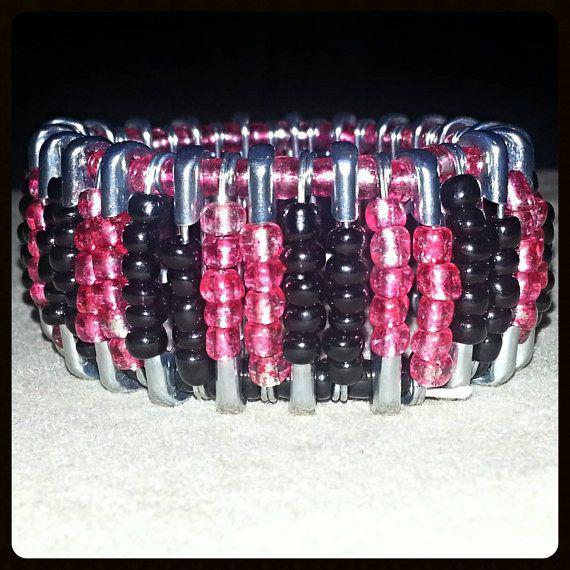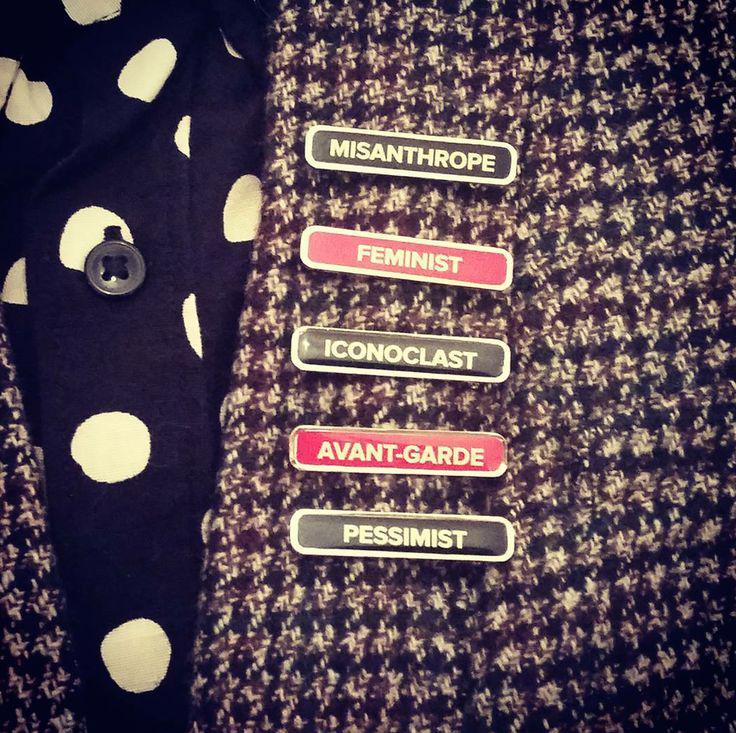The first image is the image on the left, the second image is the image on the right. Evaluate the accuracy of this statement regarding the images: "There is a bracelet in the image on the left.". Is it true? Answer yes or no. Yes. The first image is the image on the left, the second image is the image on the right. Assess this claim about the two images: "One image shows one bracelet made of beaded safety pins.". Correct or not? Answer yes or no. Yes. 